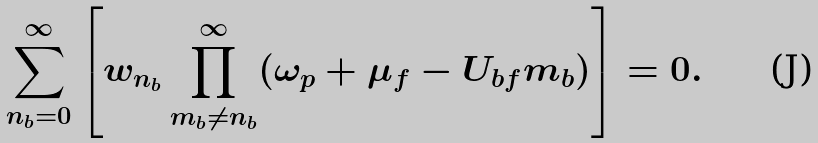<formula> <loc_0><loc_0><loc_500><loc_500>\sum _ { n _ { b } = 0 } ^ { \infty } \left [ w _ { n _ { b } } \prod _ { m _ { b } \ne n _ { b } } ^ { \infty } ( \omega _ { p } + \mu _ { f } - U _ { b f } m _ { b } ) \right ] = 0 .</formula> 